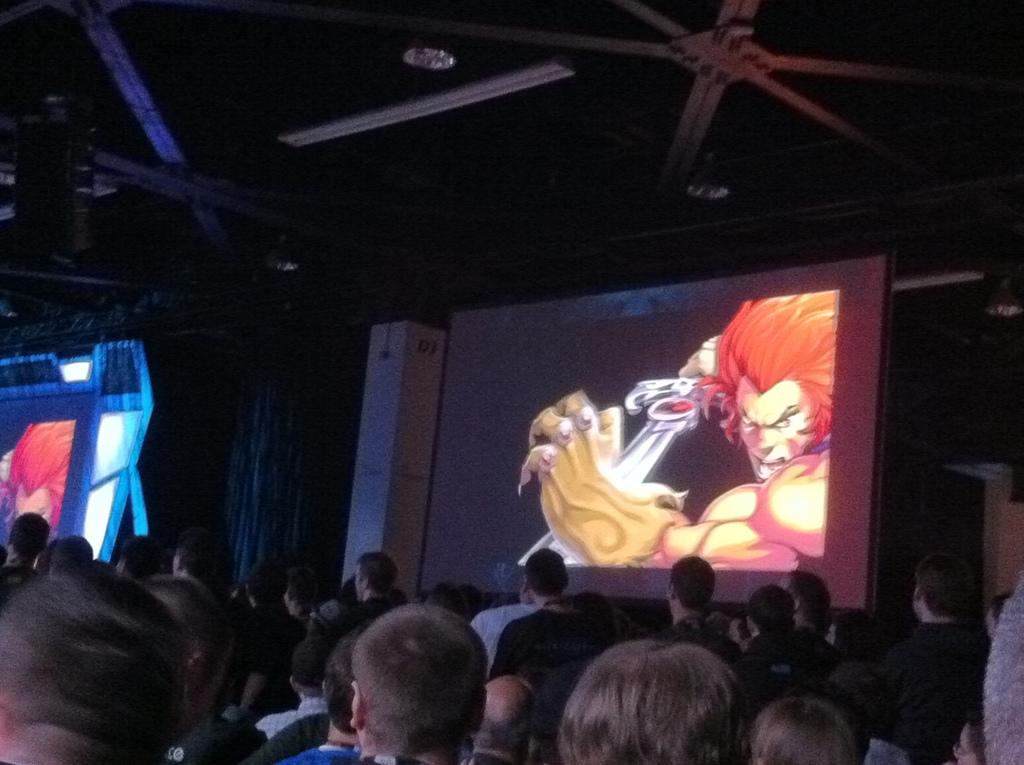Who or what can be seen in the image? There are people in the image. What is displayed on the screen in the image? There is a screen with a cartoon picture in the image. What is the cartoon picture showing? The cartoon picture depicts a person holding a sword. What can be seen on the roof in the image? There are lights on the roof in the image. What type of scarecrow is standing near the people in the image? There is no scarecrow present in the image. What holiday is being celebrated in the image? The image does not depict a specific holiday. 